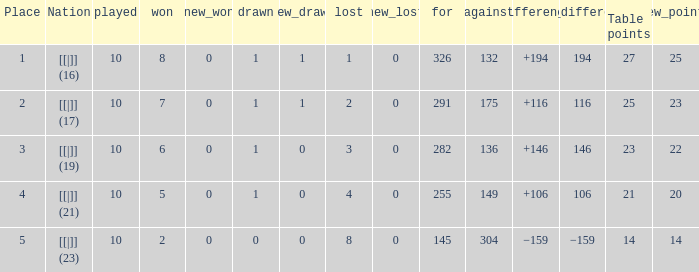 How many games had a deficit of 175?  1.0. 